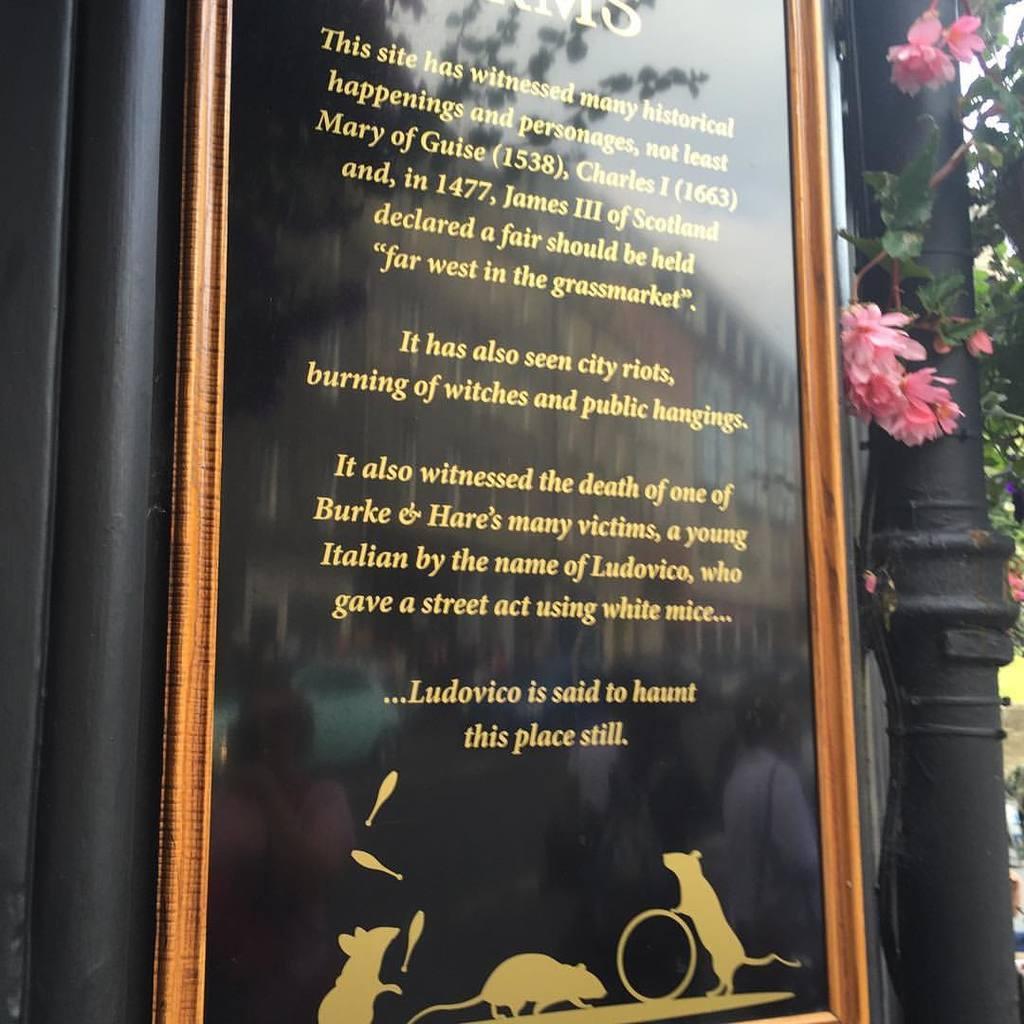In one or two sentences, can you explain what this image depicts? In the center of the image, we can see a frame placed on the wall and in the background, there is a pole and we can see a tree along with flowers. 